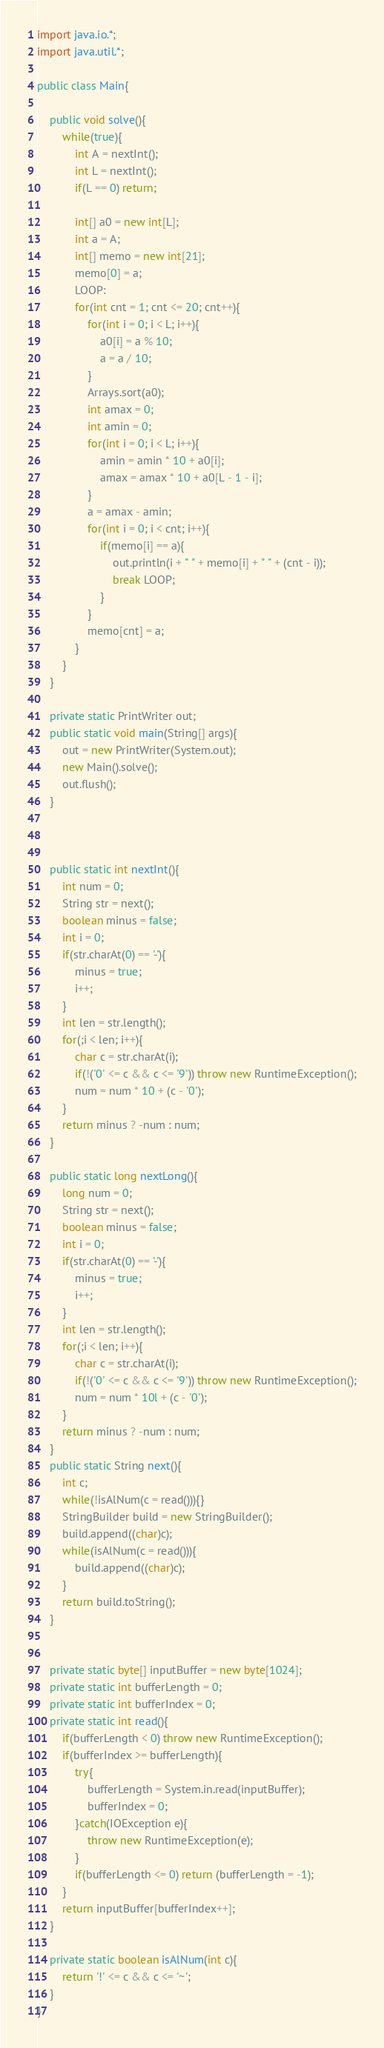<code> <loc_0><loc_0><loc_500><loc_500><_Java_>
import java.io.*;
import java.util.*;
 
public class Main{
	
	public void solve(){
		while(true){
			int A = nextInt();
			int L = nextInt();
			if(L == 0) return;
			
			int[] a0 = new int[L];
			int a = A;
			int[] memo = new int[21];
			memo[0] = a;
			LOOP:
			for(int cnt = 1; cnt <= 20; cnt++){
				for(int i = 0; i < L; i++){
					a0[i] = a % 10;
					a = a / 10;
				}
				Arrays.sort(a0);
				int amax = 0;
				int amin = 0;
				for(int i = 0; i < L; i++){
					amin = amin * 10 + a0[i];
					amax = amax * 10 + a0[L - 1 - i];
				}
				a = amax - amin;
				for(int i = 0; i < cnt; i++){
					if(memo[i] == a){
						out.println(i + " " + memo[i] + " " + (cnt - i));
						break LOOP;
					}
				}
				memo[cnt] = a;
			}
		}
	}
	
	private static PrintWriter out;
	public static void main(String[] args){
		out = new PrintWriter(System.out);
		new Main().solve();
		out.flush();
	}
	
	
	
	public static int nextInt(){
		int num = 0;
		String str = next();
		boolean minus = false;
		int i = 0;
		if(str.charAt(0) == '-'){
			minus = true;
			i++;
		}
		int len = str.length();
		for(;i < len; i++){
			char c = str.charAt(i);
			if(!('0' <= c && c <= '9')) throw new RuntimeException();
			num = num * 10 + (c - '0');
		}
		return minus ? -num : num;
	}
	
	public static long nextLong(){
		long num = 0;
		String str = next();
		boolean minus = false;
		int i = 0;
		if(str.charAt(0) == '-'){
			minus = true;
			i++;
		}
		int len = str.length();
		for(;i < len; i++){
			char c = str.charAt(i);
			if(!('0' <= c && c <= '9')) throw new RuntimeException();
			num = num * 10l + (c - '0');
		}
		return minus ? -num : num;
	}
	public static String next(){
		int c;
		while(!isAlNum(c = read())){}
		StringBuilder build = new StringBuilder();
		build.append((char)c);
		while(isAlNum(c = read())){
			build.append((char)c);
		}
		return build.toString();
	}
	
	
	private static byte[] inputBuffer = new byte[1024];
	private static int bufferLength = 0;
	private static int bufferIndex = 0;
	private static int read(){
		if(bufferLength < 0) throw new RuntimeException();
		if(bufferIndex >= bufferLength){
			try{
				bufferLength = System.in.read(inputBuffer);
				bufferIndex = 0;
			}catch(IOException e){
				throw new RuntimeException(e);
			}
			if(bufferLength <= 0) return (bufferLength = -1);
		}
		return inputBuffer[bufferIndex++];
	}
	
	private static boolean isAlNum(int c){
		return '!' <= c && c <= '~';
	}
}</code> 